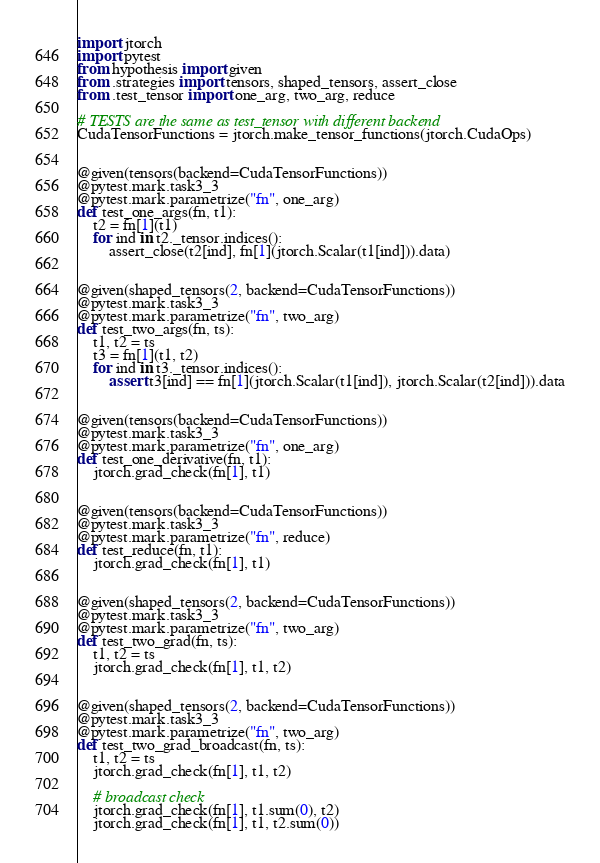<code> <loc_0><loc_0><loc_500><loc_500><_Python_>import jtorch
import pytest
from hypothesis import given
from .strategies import tensors, shaped_tensors, assert_close
from .test_tensor import one_arg, two_arg, reduce

# TESTS are the same as test_tensor with different backend
CudaTensorFunctions = jtorch.make_tensor_functions(jtorch.CudaOps)


@given(tensors(backend=CudaTensorFunctions))
@pytest.mark.task3_3
@pytest.mark.parametrize("fn", one_arg)
def test_one_args(fn, t1):
    t2 = fn[1](t1)
    for ind in t2._tensor.indices():
        assert_close(t2[ind], fn[1](jtorch.Scalar(t1[ind])).data)


@given(shaped_tensors(2, backend=CudaTensorFunctions))
@pytest.mark.task3_3
@pytest.mark.parametrize("fn", two_arg)
def test_two_args(fn, ts):
    t1, t2 = ts
    t3 = fn[1](t1, t2)
    for ind in t3._tensor.indices():
        assert t3[ind] == fn[1](jtorch.Scalar(t1[ind]), jtorch.Scalar(t2[ind])).data


@given(tensors(backend=CudaTensorFunctions))
@pytest.mark.task3_3
@pytest.mark.parametrize("fn", one_arg)
def test_one_derivative(fn, t1):
    jtorch.grad_check(fn[1], t1)


@given(tensors(backend=CudaTensorFunctions))
@pytest.mark.task3_3
@pytest.mark.parametrize("fn", reduce)
def test_reduce(fn, t1):
    jtorch.grad_check(fn[1], t1)


@given(shaped_tensors(2, backend=CudaTensorFunctions))
@pytest.mark.task3_3
@pytest.mark.parametrize("fn", two_arg)
def test_two_grad(fn, ts):
    t1, t2 = ts
    jtorch.grad_check(fn[1], t1, t2)


@given(shaped_tensors(2, backend=CudaTensorFunctions))
@pytest.mark.task3_3
@pytest.mark.parametrize("fn", two_arg)
def test_two_grad_broadcast(fn, ts):
    t1, t2 = ts
    jtorch.grad_check(fn[1], t1, t2)

    # broadcast check
    jtorch.grad_check(fn[1], t1.sum(0), t2)
    jtorch.grad_check(fn[1], t1, t2.sum(0))
</code> 